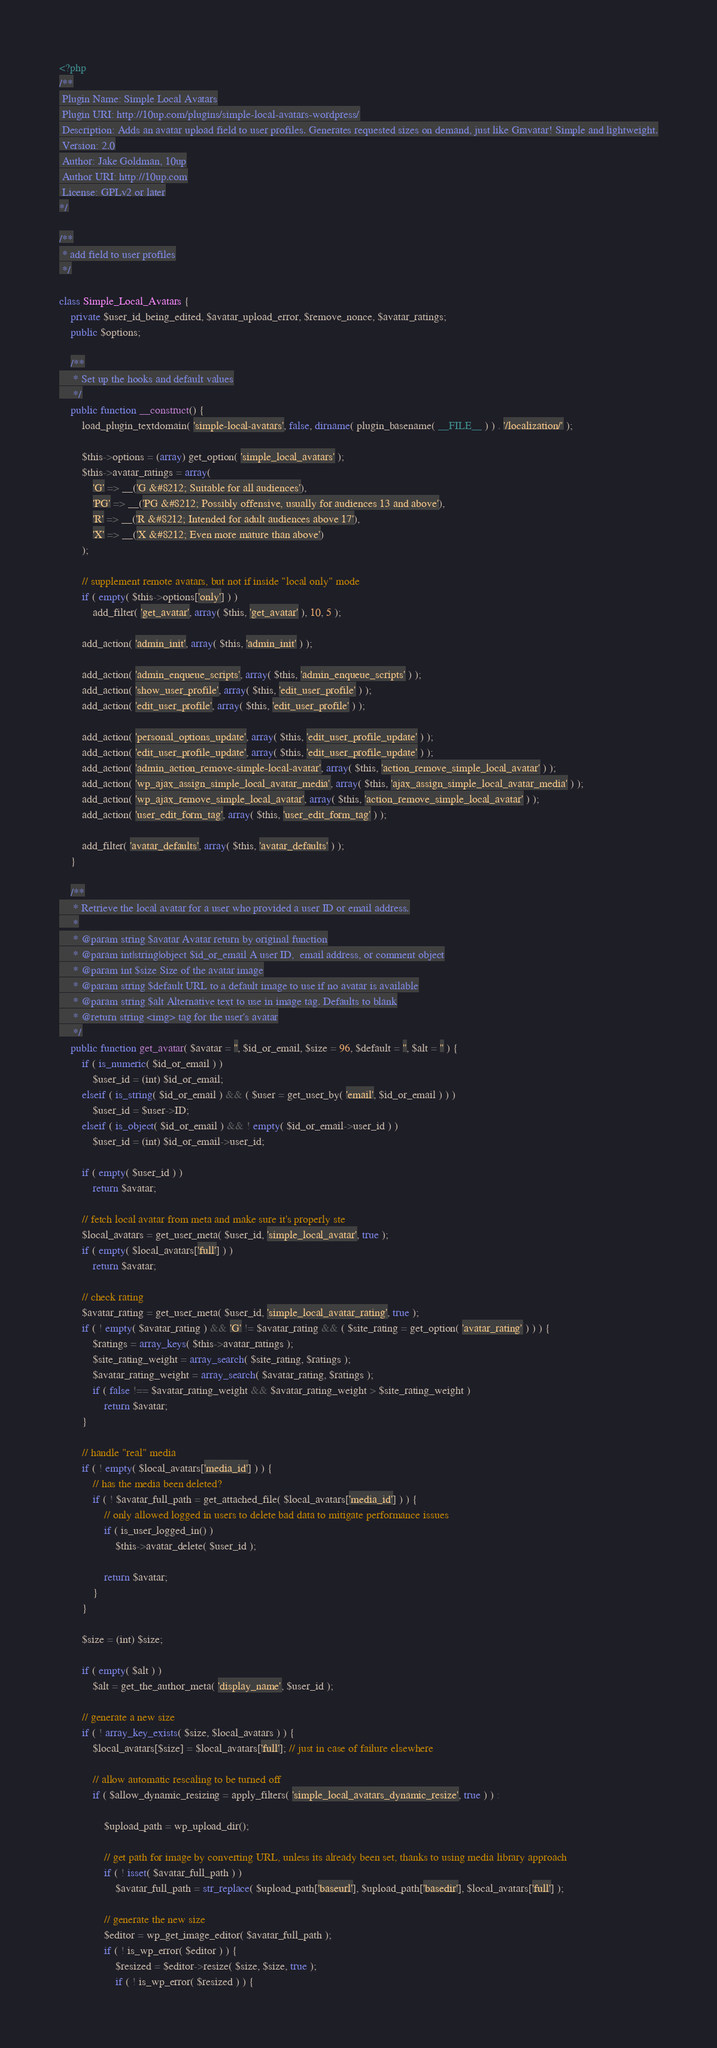Convert code to text. <code><loc_0><loc_0><loc_500><loc_500><_PHP_><?php
/**
 Plugin Name: Simple Local Avatars
 Plugin URI: http://10up.com/plugins/simple-local-avatars-wordpress/
 Description: Adds an avatar upload field to user profiles. Generates requested sizes on demand, just like Gravatar! Simple and lightweight.
 Version: 2.0
 Author: Jake Goldman, 10up
 Author URI: http://10up.com
 License: GPLv2 or later
*/

/**
 * add field to user profiles
 */
 
class Simple_Local_Avatars {
	private $user_id_being_edited, $avatar_upload_error, $remove_nonce, $avatar_ratings;
	public $options;

	/**
	 * Set up the hooks and default values
	 */
	public function __construct() {
		load_plugin_textdomain( 'simple-local-avatars', false, dirname( plugin_basename( __FILE__ ) ) . '/localization/' );

		$this->options = (array) get_option( 'simple_local_avatars' );
		$this->avatar_ratings = array(
			'G' => __('G &#8212; Suitable for all audiences'),
			'PG' => __('PG &#8212; Possibly offensive, usually for audiences 13 and above'),
			'R' => __('R &#8212; Intended for adult audiences above 17'),
			'X' => __('X &#8212; Even more mature than above')
		);

		// supplement remote avatars, but not if inside "local only" mode
		if ( empty( $this->options['only'] ) )
			add_filter( 'get_avatar', array( $this, 'get_avatar' ), 10, 5 );
		
		add_action( 'admin_init', array( $this, 'admin_init' ) );

		add_action( 'admin_enqueue_scripts', array( $this, 'admin_enqueue_scripts' ) );
		add_action( 'show_user_profile', array( $this, 'edit_user_profile' ) );
		add_action( 'edit_user_profile', array( $this, 'edit_user_profile' ) );
		
		add_action( 'personal_options_update', array( $this, 'edit_user_profile_update' ) );
		add_action( 'edit_user_profile_update', array( $this, 'edit_user_profile_update' ) );
		add_action( 'admin_action_remove-simple-local-avatar', array( $this, 'action_remove_simple_local_avatar' ) );
		add_action( 'wp_ajax_assign_simple_local_avatar_media', array( $this, 'ajax_assign_simple_local_avatar_media' ) );
		add_action( 'wp_ajax_remove_simple_local_avatar', array( $this, 'action_remove_simple_local_avatar' ) );
		add_action( 'user_edit_form_tag', array( $this, 'user_edit_form_tag' ) );
		
		add_filter( 'avatar_defaults', array( $this, 'avatar_defaults' ) );
	}

	/**
	 * Retrieve the local avatar for a user who provided a user ID or email address.
	 *
	 * @param string $avatar Avatar return by original function
	 * @param int|string|object $id_or_email A user ID,  email address, or comment object
	 * @param int $size Size of the avatar image
	 * @param string $default URL to a default image to use if no avatar is available
	 * @param string $alt Alternative text to use in image tag. Defaults to blank
	 * @return string <img> tag for the user's avatar
	 */
	public function get_avatar( $avatar = '', $id_or_email, $size = 96, $default = '', $alt = '' ) {
		if ( is_numeric( $id_or_email ) )
			$user_id = (int) $id_or_email;
		elseif ( is_string( $id_or_email ) && ( $user = get_user_by( 'email', $id_or_email ) ) )
			$user_id = $user->ID;
		elseif ( is_object( $id_or_email ) && ! empty( $id_or_email->user_id ) )
			$user_id = (int) $id_or_email->user_id;
		
		if ( empty( $user_id ) )
			return $avatar;

		// fetch local avatar from meta and make sure it's properly ste
		$local_avatars = get_user_meta( $user_id, 'simple_local_avatar', true );
		if ( empty( $local_avatars['full'] ) )
			return $avatar;

		// check rating
		$avatar_rating = get_user_meta( $user_id, 'simple_local_avatar_rating', true );
		if ( ! empty( $avatar_rating ) && 'G' != $avatar_rating && ( $site_rating = get_option( 'avatar_rating' ) ) ) {
			$ratings = array_keys( $this->avatar_ratings );
			$site_rating_weight = array_search( $site_rating, $ratings );
			$avatar_rating_weight = array_search( $avatar_rating, $ratings );
			if ( false !== $avatar_rating_weight && $avatar_rating_weight > $site_rating_weight )
				return $avatar;
		}

		// handle "real" media
		if ( ! empty( $local_avatars['media_id'] ) ) {
			// has the media been deleted?
			if ( ! $avatar_full_path = get_attached_file( $local_avatars['media_id'] ) ) {
				// only allowed logged in users to delete bad data to mitigate performance issues
				if ( is_user_logged_in() )
					$this->avatar_delete( $user_id );

				return $avatar;
			}
		}

		$size = (int) $size;
			
		if ( empty( $alt ) )
			$alt = get_the_author_meta( 'display_name', $user_id );
			
		// generate a new size
		if ( ! array_key_exists( $size, $local_avatars ) ) {
			$local_avatars[$size] = $local_avatars['full']; // just in case of failure elsewhere

			// allow automatic rescaling to be turned off
			if ( $allow_dynamic_resizing = apply_filters( 'simple_local_avatars_dynamic_resize', true ) ) :

				$upload_path = wp_upload_dir();

				// get path for image by converting URL, unless its already been set, thanks to using media library approach
				if ( ! isset( $avatar_full_path ) )
					$avatar_full_path = str_replace( $upload_path['baseurl'], $upload_path['basedir'], $local_avatars['full'] );

				// generate the new size
				$editor = wp_get_image_editor( $avatar_full_path );
				if ( ! is_wp_error( $editor ) ) {
					$resized = $editor->resize( $size, $size, true );
					if ( ! is_wp_error( $resized ) ) {</code> 